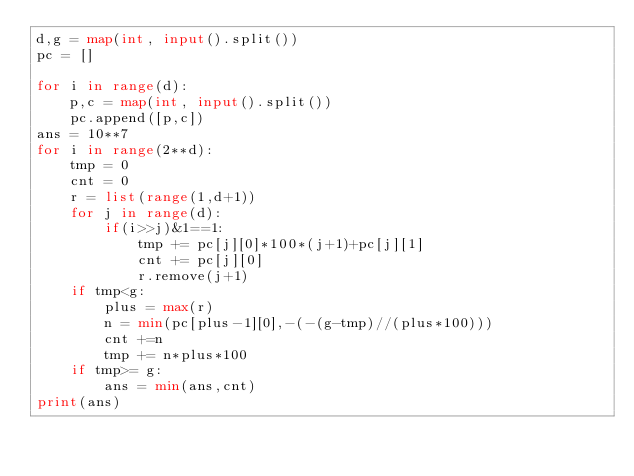Convert code to text. <code><loc_0><loc_0><loc_500><loc_500><_Python_>d,g = map(int, input().split())
pc = []

for i in range(d):
    p,c = map(int, input().split())
    pc.append([p,c])
ans = 10**7
for i in range(2**d):
    tmp = 0
    cnt = 0
    r = list(range(1,d+1))
    for j in range(d):
        if(i>>j)&1==1:
            tmp += pc[j][0]*100*(j+1)+pc[j][1]
            cnt += pc[j][0]
            r.remove(j+1)
    if tmp<g:
        plus = max(r)
        n = min(pc[plus-1][0],-(-(g-tmp)//(plus*100)))
        cnt +=n
        tmp += n*plus*100
    if tmp>= g:
        ans = min(ans,cnt)
print(ans)</code> 